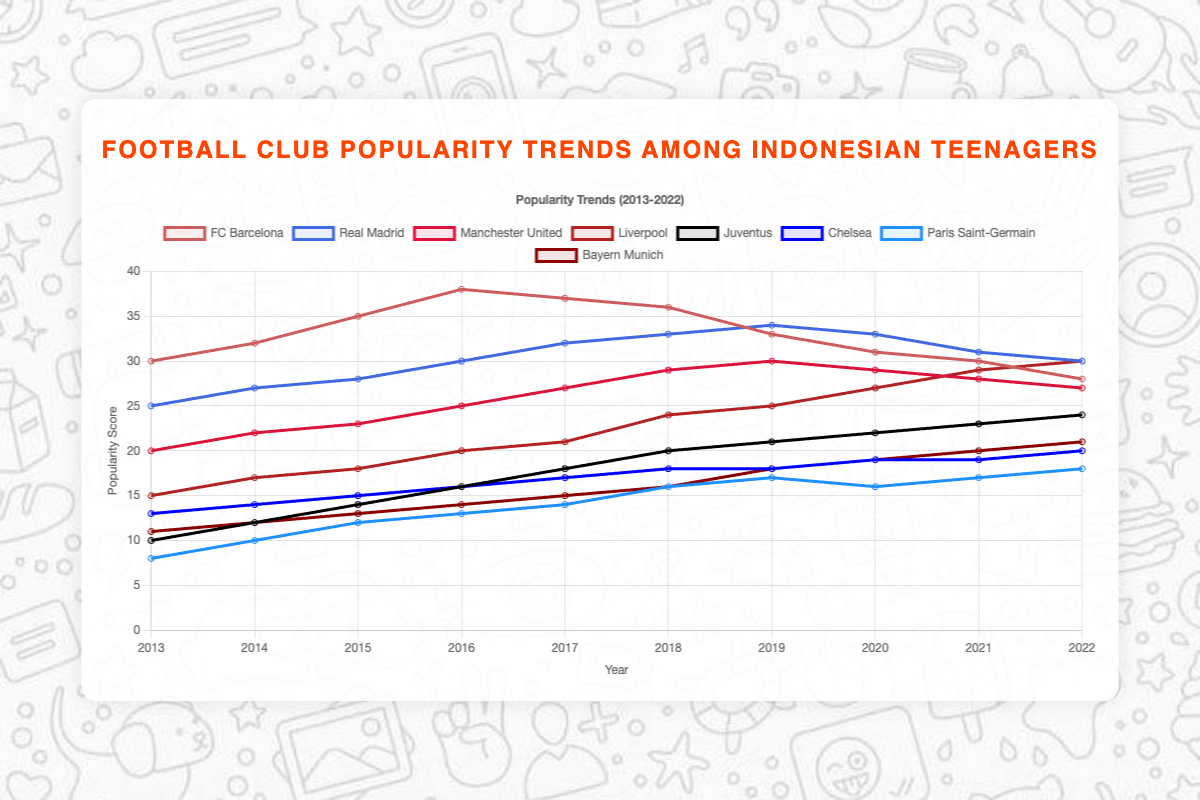Which club was most popular among Indonesian teenagers in 2013? In 2013, the club with the highest popularity score is FC Barcelona, which is represented by the highest point on the chart for that year.
Answer: FC Barcelona Which two clubs had equal popularity scores in 2020? In 2020, the plotted lines for Manchester United and Real Madrid intersect, indicating both clubs had the same popularity score of 29 in that year.
Answer: Manchester United and Real Madrid What was the percentage change in popularity for Liverpool from 2013 to 2022? The popularity score for Liverpool in 2013 was 15, and it increased to 30 by 2022. The percentage change is calculated as ((30 - 15) / 15) * 100 = 100%.
Answer: 100% Which club showed a consistently increasing trend in popularity over the entire decade? Juventus consistently showed an increasing trend from 10 in 2013 to 24 in 2022 without any decrease in the popularity score.
Answer: Juventus What is the total sum of popularity scores for FC Barcelona across all years? The total sum is obtained by adding the popularity scores of FC Barcelona for each year: 30 + 32 + 35 + 38 + 37 + 36 + 33 + 31 + 30 + 28 = 330.
Answer: 330 Between 2015 and 2017, which club's popularity increased the most? From 2015 to 2017, Juventus had an increase of 4 points (14 to 18), which is the highest among all clubs when comparing the changes in their popularity scores over this period.
Answer: Juventus Which clubs have seen their popularity score decrease between 2019 and 2022? FC Barcelona and Manchester United experienced decreases in their popularity scores between 2019 and 2022, as indicated by downward trends in their respective lines. Barcelona decreased from 33 to 28 and Manchester United from 30 to 27.
Answer: FC Barcelona and Manchester United How did the popularity of Bayern Munich compare to that of Paris Saint-Germain in 2022? In 2022, Bayern Munich's popularity score was 21, while Paris Saint-Germain's was 18. Therefore, Bayern Munich was more popular than Paris Saint-Germain.
Answer: Bayern Munich was more popular Calculate the average popularity score of Real Madrid over the decade. The average score is calculated by summing all the popularity scores for Real Madrid: (25 + 27 + 28 + 30 + 32 + 33 + 34 + 33 + 31 + 30) = 303. The average is 303 / 10 = 30.3.
Answer: 30.3 Which club had the least popularity among Indonesian teenagers in 2013 and how did this change by 2022? Paris Saint-Germain was the least popular in 2013 with a score of 8, and by 2022 their popularity increased to 18, showing a significant rise over the decade.
Answer: Paris Saint-Germain; increased to 18 